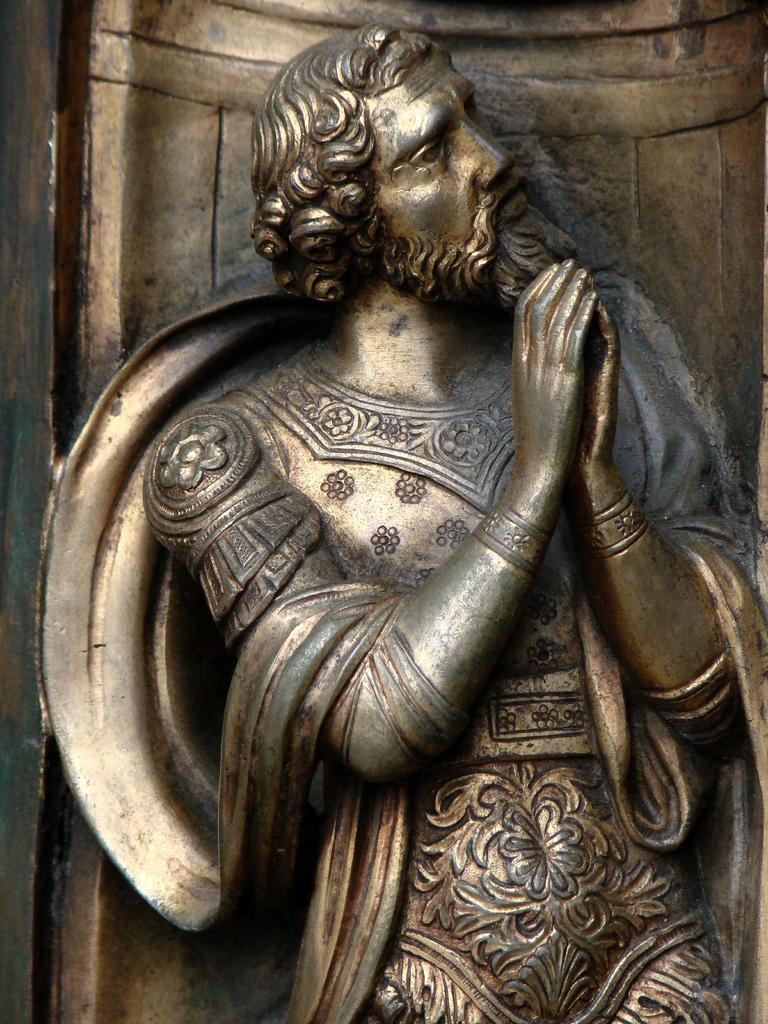Describe this image in one or two sentences. This is sculpture of a man. 